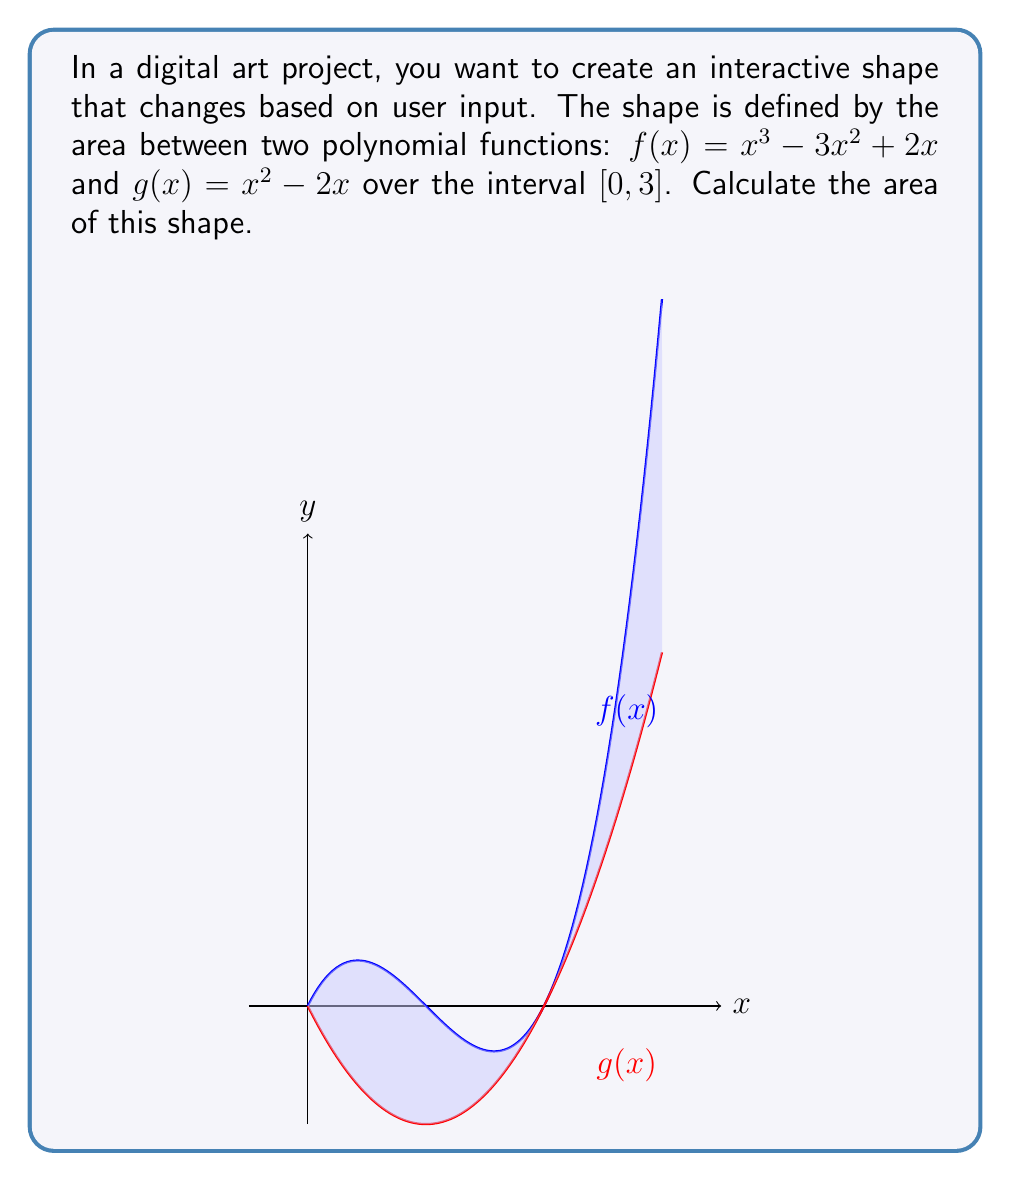What is the answer to this math problem? To find the area between two functions, we need to:
1. Find the difference between the upper and lower functions
2. Integrate this difference over the given interval

Step 1: Determine which function is on top
For $x \in [0, 3]$, $f(x) \geq g(x)$, so $f(x)$ is the upper function.

Step 2: Set up the integral
Area $= \int_0^3 [f(x) - g(x)] dx$
$= \int_0^3 [(x^3 - 3x^2 + 2x) - (x^2 - 2x)] dx$
$= \int_0^3 (x^3 - 4x^2 + 4x) dx$

Step 3: Integrate
$= [\frac{1}{4}x^4 - \frac{4}{3}x^3 + 2x^2]_0^3$

Step 4: Evaluate the integral
$= (\frac{1}{4}(3^4) - \frac{4}{3}(3^3) + 2(3^2)) - (\frac{1}{4}(0^4) - \frac{4}{3}(0^3) + 2(0^2))$
$= (20.25 - 36 + 18) - 0$
$= 2.25$

Therefore, the area between the functions is 2.25 square units.
Answer: $2.25$ square units 